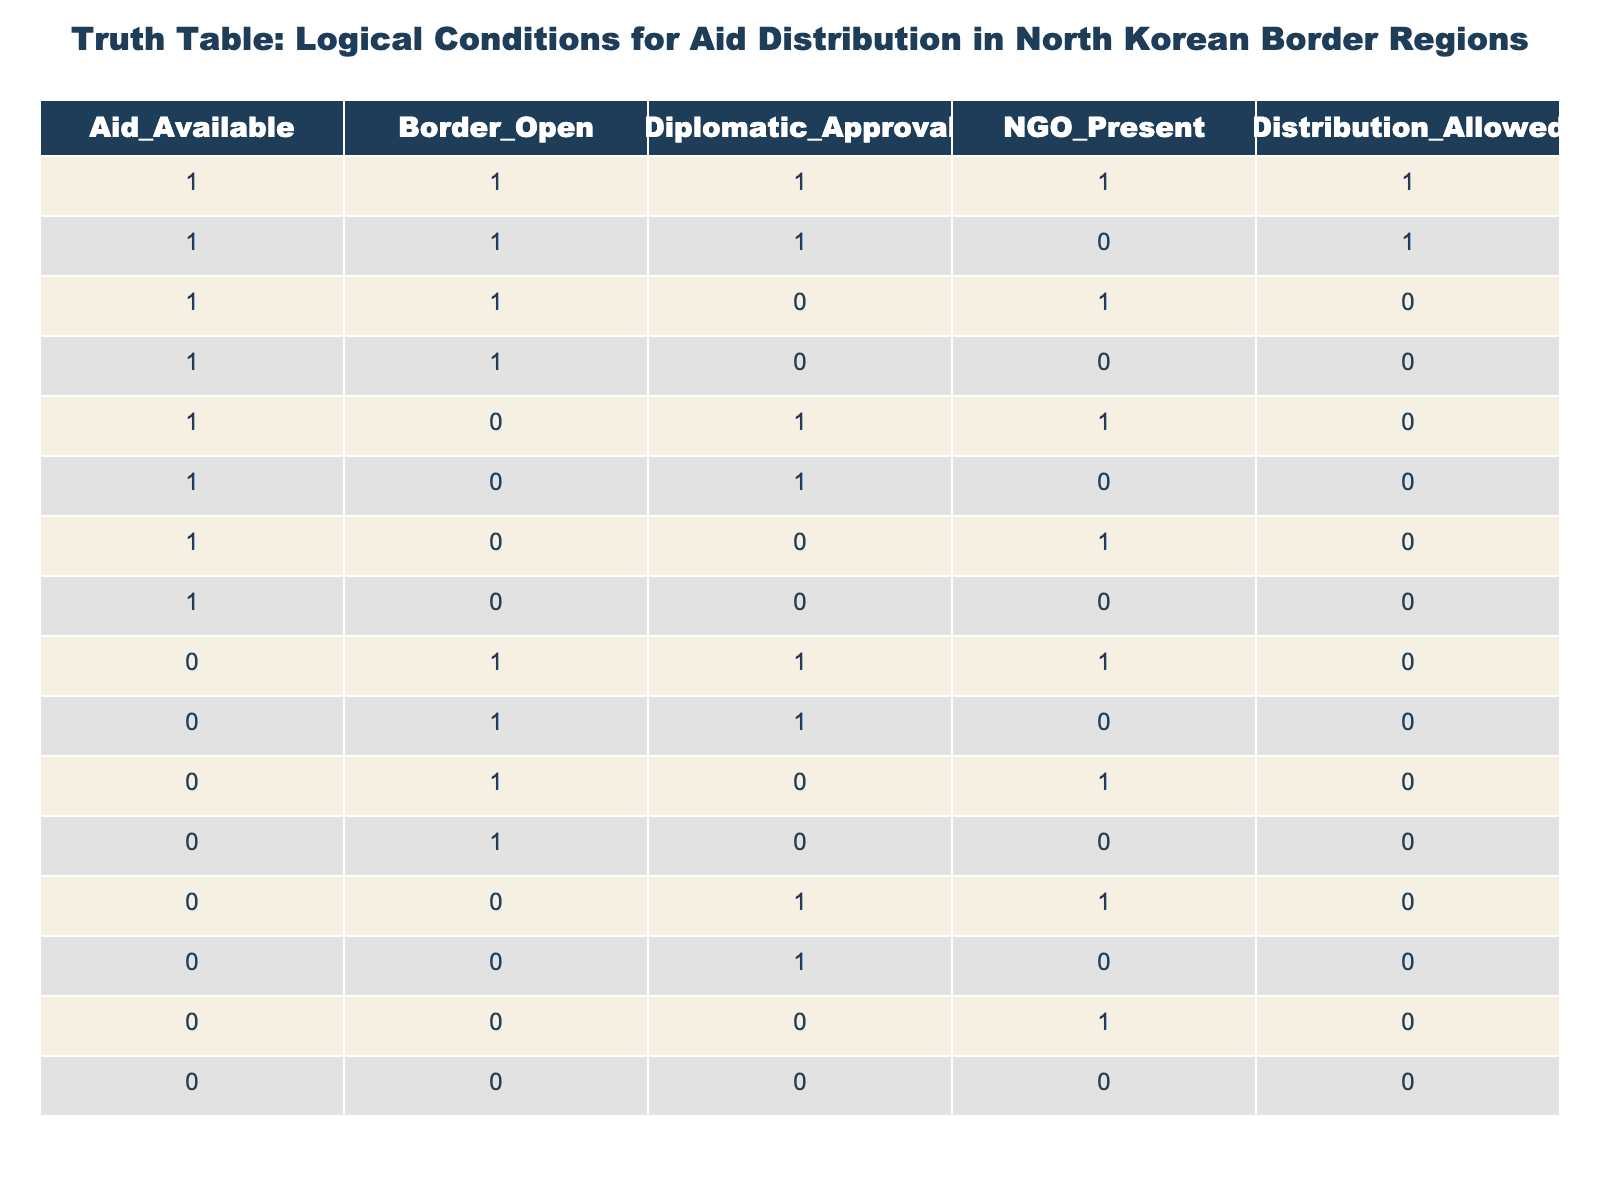What is the total number of rows where aid distribution is allowed? In the table, we count the rows where the 'Distribution_Allowed' value is 1. There are 3 such rows (the first two rows and the third row)
Answer: 3 What is the value of 'Distribution_Allowed' when both 'Border_Open' and 'Diplomatic_Approval' are 0? We look for the row where both 'Border_Open' and 'Diplomatic_Approval' are 0. The only row that meets these conditions has 'Distribution_Allowed' equal to 0.
Answer: 0 Is there diplomatic approval when there is aid available and a NGO is present? We need to find rows where 'Aid_Available' is 1 and 'NGO_Present' is 1. In this case, there are 2 rows: the first row has 'Diplomatic_Approval' as 1, confirming that there is approval.
Answer: Yes What percentage of cases with aid available also have distribution allowed? We calculate the cases with aid available ('Aid_Available' = 1), which total 7 rows. Out of these, 3 have distribution allowed. The percentage is (3/7) * 100, which equals approximately 42.86%.
Answer: 42.86% If a NGO is not present, what is the number of rows where distribution is allowed? We need to look at the rows where 'NGO_Present' is 0. There are 5 rows that meet this condition, out of which 0 rows allow distribution (as 'Distribution_Allowed' is 0 for all).
Answer: 0 What is the relationship between 'Border_Open' being 1 and 'Distribution_Allowed'? We observe the rows where 'Border_Open' is 1; there are 5 such rows, of which 3 allow distribution and 2 do not. This indicates that having the border open supports but does not guarantee distribution.
Answer: Mixed Can distribution occur if the border is closed but there is diplomatic approval? We find rows where 'Border_Open' is 0 and 'Diplomatic_Approval' is 1. There are 3 such rows, and all have 'Distribution_Allowed' as 0, indicating that distribution does not occur under these conditions.
Answer: No What is the total number of rows where both 'Aid_Available' and 'NGO_Present' are 1? We search through the table for rows where both 'Aid_Available' and 'NGO_Present' are 1. There are only 2 rows that meet this criteria.
Answer: 2 In how many cases does having both diplomatic approval and an NGO present lead to allowed distribution? We look for rows where both 'Diplomatic_Approval' and 'NGO_Present' are 1. There is 1 such row which allows distribution. Thus, having these two conditions leads to distribution being granted only once in the data presented.
Answer: 1 